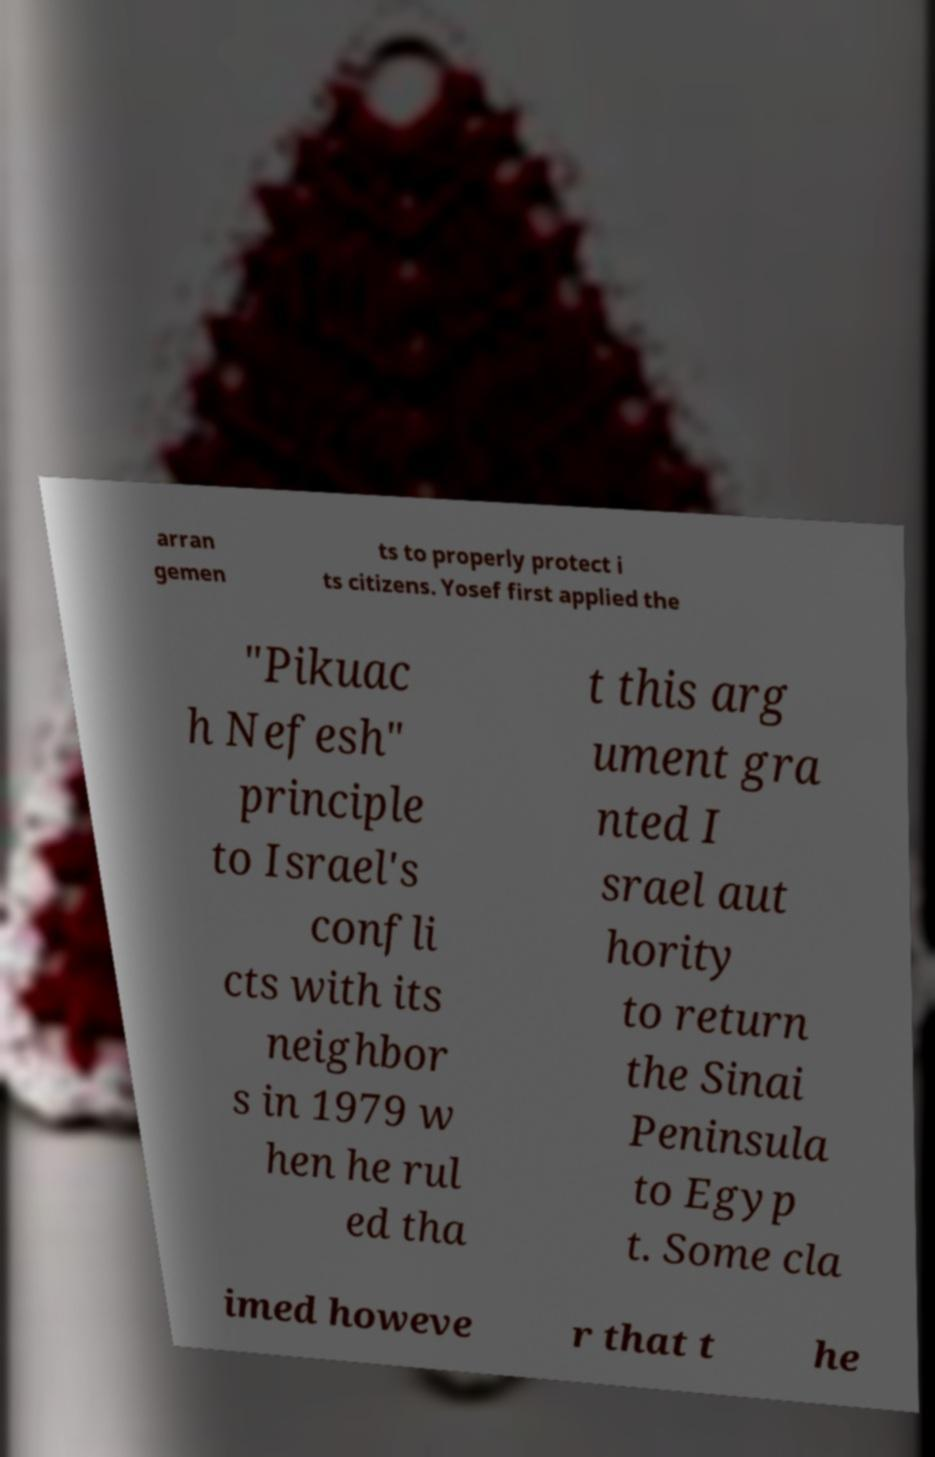Please identify and transcribe the text found in this image. arran gemen ts to properly protect i ts citizens. Yosef first applied the "Pikuac h Nefesh" principle to Israel's confli cts with its neighbor s in 1979 w hen he rul ed tha t this arg ument gra nted I srael aut hority to return the Sinai Peninsula to Egyp t. Some cla imed howeve r that t he 